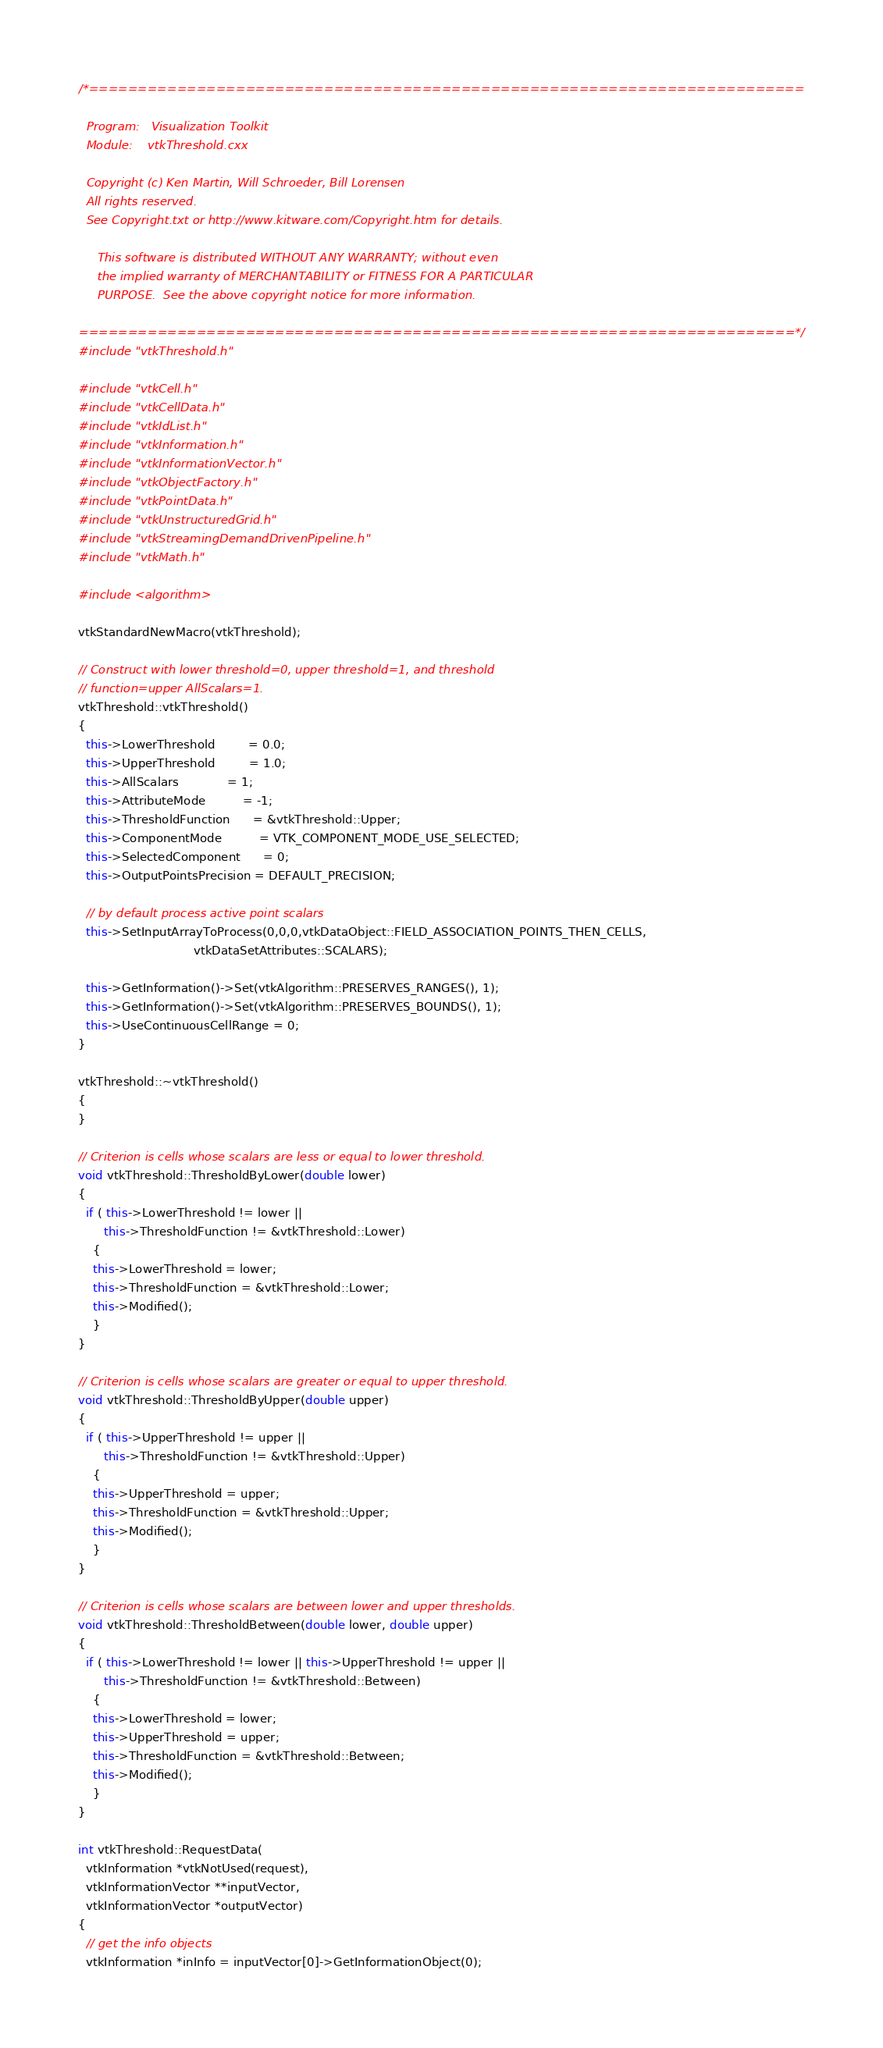Convert code to text. <code><loc_0><loc_0><loc_500><loc_500><_C++_>/*=========================================================================

  Program:   Visualization Toolkit
  Module:    vtkThreshold.cxx

  Copyright (c) Ken Martin, Will Schroeder, Bill Lorensen
  All rights reserved.
  See Copyright.txt or http://www.kitware.com/Copyright.htm for details.

     This software is distributed WITHOUT ANY WARRANTY; without even
     the implied warranty of MERCHANTABILITY or FITNESS FOR A PARTICULAR
     PURPOSE.  See the above copyright notice for more information.

=========================================================================*/
#include "vtkThreshold.h"

#include "vtkCell.h"
#include "vtkCellData.h"
#include "vtkIdList.h"
#include "vtkInformation.h"
#include "vtkInformationVector.h"
#include "vtkObjectFactory.h"
#include "vtkPointData.h"
#include "vtkUnstructuredGrid.h"
#include "vtkStreamingDemandDrivenPipeline.h"
#include "vtkMath.h"

#include <algorithm>

vtkStandardNewMacro(vtkThreshold);

// Construct with lower threshold=0, upper threshold=1, and threshold
// function=upper AllScalars=1.
vtkThreshold::vtkThreshold()
{
  this->LowerThreshold         = 0.0;
  this->UpperThreshold         = 1.0;
  this->AllScalars             = 1;
  this->AttributeMode          = -1;
  this->ThresholdFunction      = &vtkThreshold::Upper;
  this->ComponentMode          = VTK_COMPONENT_MODE_USE_SELECTED;
  this->SelectedComponent      = 0;
  this->OutputPointsPrecision = DEFAULT_PRECISION;

  // by default process active point scalars
  this->SetInputArrayToProcess(0,0,0,vtkDataObject::FIELD_ASSOCIATION_POINTS_THEN_CELLS,
                               vtkDataSetAttributes::SCALARS);

  this->GetInformation()->Set(vtkAlgorithm::PRESERVES_RANGES(), 1);
  this->GetInformation()->Set(vtkAlgorithm::PRESERVES_BOUNDS(), 1);
  this->UseContinuousCellRange = 0;
}

vtkThreshold::~vtkThreshold()
{
}

// Criterion is cells whose scalars are less or equal to lower threshold.
void vtkThreshold::ThresholdByLower(double lower)
{
  if ( this->LowerThreshold != lower ||
       this->ThresholdFunction != &vtkThreshold::Lower)
    {
    this->LowerThreshold = lower;
    this->ThresholdFunction = &vtkThreshold::Lower;
    this->Modified();
    }
}

// Criterion is cells whose scalars are greater or equal to upper threshold.
void vtkThreshold::ThresholdByUpper(double upper)
{
  if ( this->UpperThreshold != upper ||
       this->ThresholdFunction != &vtkThreshold::Upper)
    {
    this->UpperThreshold = upper;
    this->ThresholdFunction = &vtkThreshold::Upper;
    this->Modified();
    }
}

// Criterion is cells whose scalars are between lower and upper thresholds.
void vtkThreshold::ThresholdBetween(double lower, double upper)
{
  if ( this->LowerThreshold != lower || this->UpperThreshold != upper ||
       this->ThresholdFunction != &vtkThreshold::Between)
    {
    this->LowerThreshold = lower;
    this->UpperThreshold = upper;
    this->ThresholdFunction = &vtkThreshold::Between;
    this->Modified();
    }
}

int vtkThreshold::RequestData(
  vtkInformation *vtkNotUsed(request),
  vtkInformationVector **inputVector,
  vtkInformationVector *outputVector)
{
  // get the info objects
  vtkInformation *inInfo = inputVector[0]->GetInformationObject(0);</code> 